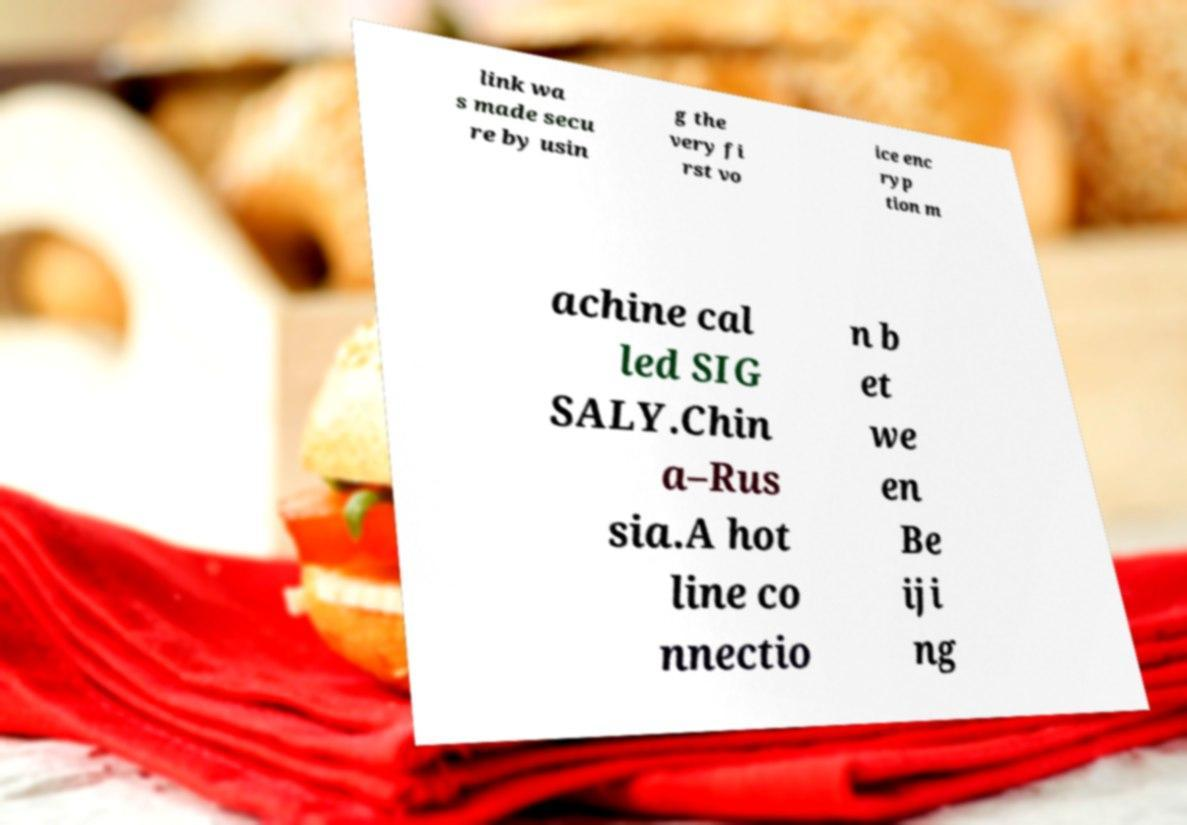I need the written content from this picture converted into text. Can you do that? link wa s made secu re by usin g the very fi rst vo ice enc ryp tion m achine cal led SIG SALY.Chin a–Rus sia.A hot line co nnectio n b et we en Be iji ng 